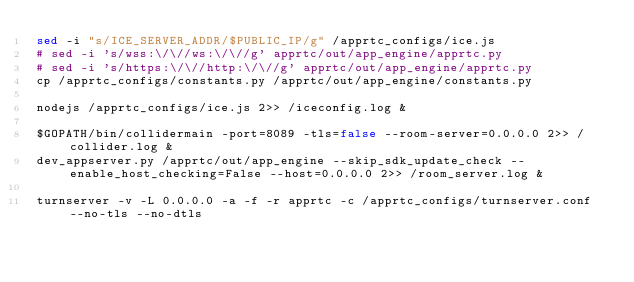<code> <loc_0><loc_0><loc_500><loc_500><_Bash_>sed -i "s/ICE_SERVER_ADDR/$PUBLIC_IP/g" /apprtc_configs/ice.js
# sed -i 's/wss:\/\//ws:\/\//g' apprtc/out/app_engine/apprtc.py
# sed -i 's/https:\/\//http:\/\//g' apprtc/out/app_engine/apprtc.py
cp /apprtc_configs/constants.py /apprtc/out/app_engine/constants.py

nodejs /apprtc_configs/ice.js 2>> /iceconfig.log &

$GOPATH/bin/collidermain -port=8089 -tls=false --room-server=0.0.0.0 2>> /collider.log &
dev_appserver.py /apprtc/out/app_engine --skip_sdk_update_check --enable_host_checking=False --host=0.0.0.0 2>> /room_server.log &

turnserver -v -L 0.0.0.0 -a -f -r apprtc -c /apprtc_configs/turnserver.conf --no-tls --no-dtls
</code> 